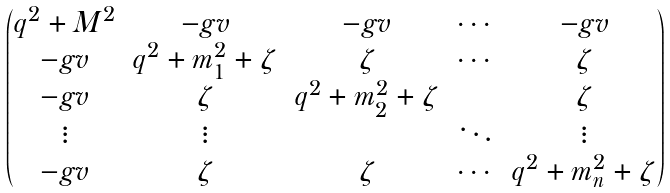<formula> <loc_0><loc_0><loc_500><loc_500>\begin{pmatrix} q ^ { 2 } + M ^ { 2 } & - g v & - g v & \cdots & - g v \\ - g v & q ^ { 2 } + m _ { 1 } ^ { 2 } + \zeta & \zeta & \cdots & \zeta \\ - g v & \zeta & q ^ { 2 } + m _ { 2 } ^ { 2 } + \zeta & & \zeta \\ \vdots & \vdots & & \ddots & \vdots \\ - g v & \zeta & \zeta & \cdots & q ^ { 2 } + m _ { n } ^ { 2 } + \zeta \end{pmatrix}</formula> 